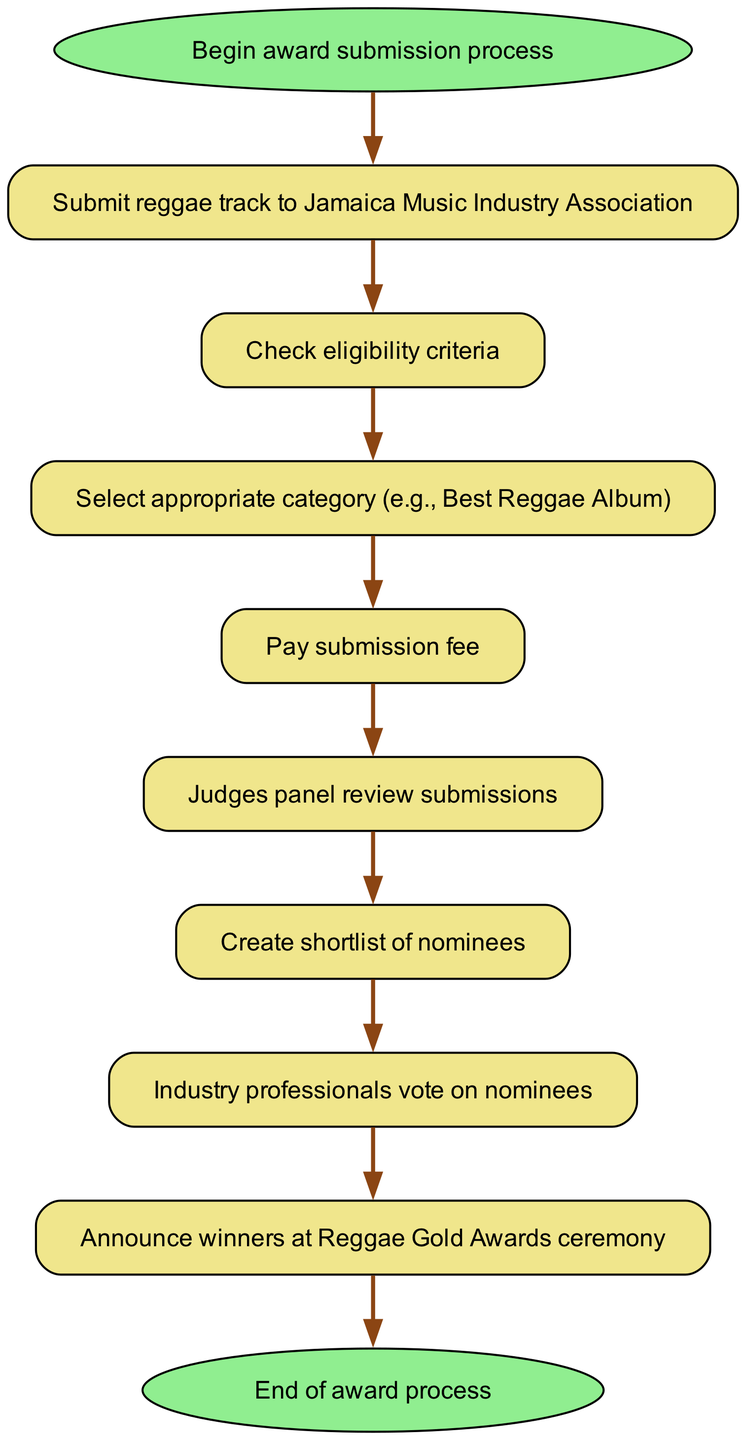What is the first step in the award submission process? The diagram starts with the node labeled "Begin award submission process," which indicates the initial step that unfolds the entire process of submitting an award.
Answer: Begin award submission process How many nodes are present in the diagram? Upon examining the diagram, we can count the nodes labeled as different steps in the process. There are a total of ten nodes before reaching the end.
Answer: Ten What comes after the submission of the reggae track? The diagram indicates that after submitting the reggae track, the next step leads to checking eligibility criteria, as shown by the direct connection from "Submit reggae track to Jamaica Music Industry Association" to "Check eligibility criteria."
Answer: Check eligibility criteria What is the last action taken in the award process? Looking at the final steps in the diagram, the last action taken before the process concludes is to announce the winners, before reaching the end of the diagram.
Answer: Announce winners at Reggae Gold Awards ceremony How many connections are outlined in the flowchart? By analyzing the connections in the diagram, we can identify the flow between each of the nodes. There are a total of nine connections that depict the process flow from start to end.
Answer: Nine What must be done before the judges panel reviews submissions? The diagram shows that before the judges panel can review submissions, the submission fee must be paid, indicating the steps leading up to the review phase.
Answer: Pay submission fee Which node represents the step where industry professionals vote? The diagram clearly identifies the voting process with a node labeled "Industry professionals vote on nominees," which comes after the shortlist is created.
Answer: Industry professionals vote on nominees What is the appropriate action to take after selecting the category? According to the flow, the action that follows selecting the appropriate category is to pay the submission fee, as indicated by the direct flow in the diagram.
Answer: Pay submission fee 